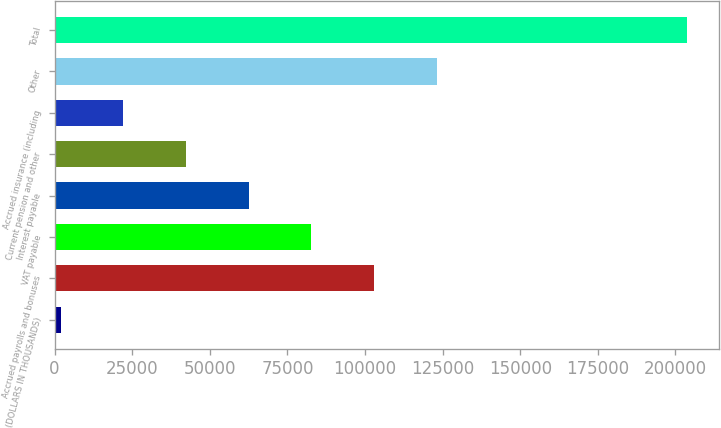<chart> <loc_0><loc_0><loc_500><loc_500><bar_chart><fcel>(DOLLARS IN THOUSANDS)<fcel>Accrued payrolls and bonuses<fcel>VAT payable<fcel>Interest payable<fcel>Current pension and other<fcel>Accrued insurance (including<fcel>Other<fcel>Total<nl><fcel>2011<fcel>102923<fcel>82740.6<fcel>62558.2<fcel>42375.8<fcel>22193.4<fcel>123105<fcel>203835<nl></chart> 